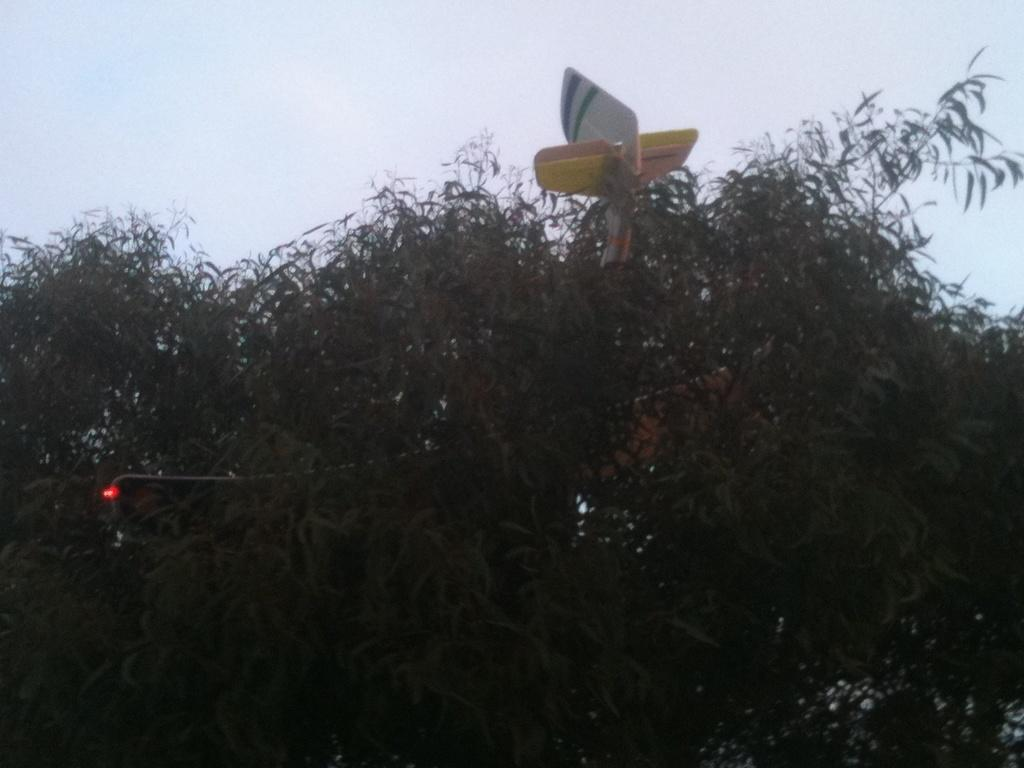What type of vegetation can be seen in the image? There are leaves in the image. What color is the light visible in the image? There is a red light in the image. Can you describe the unspecified "thing" in the image? Unfortunately, the provided facts do not give enough information to describe the "thing" in the image. What can be seen in the background of the image? The sky is visible in the background of the image. What type of vegetable is being discussed in the image? There is no vegetable mentioned or depicted in the image. What beliefs are held by the group in the image? There is no group or any indication of beliefs in the image. 